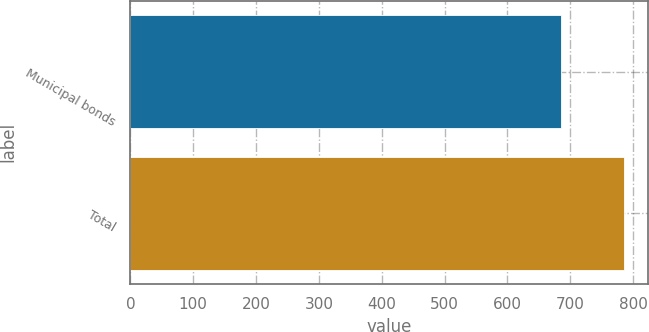Convert chart. <chart><loc_0><loc_0><loc_500><loc_500><bar_chart><fcel>Municipal bonds<fcel>Total<nl><fcel>685<fcel>785<nl></chart> 